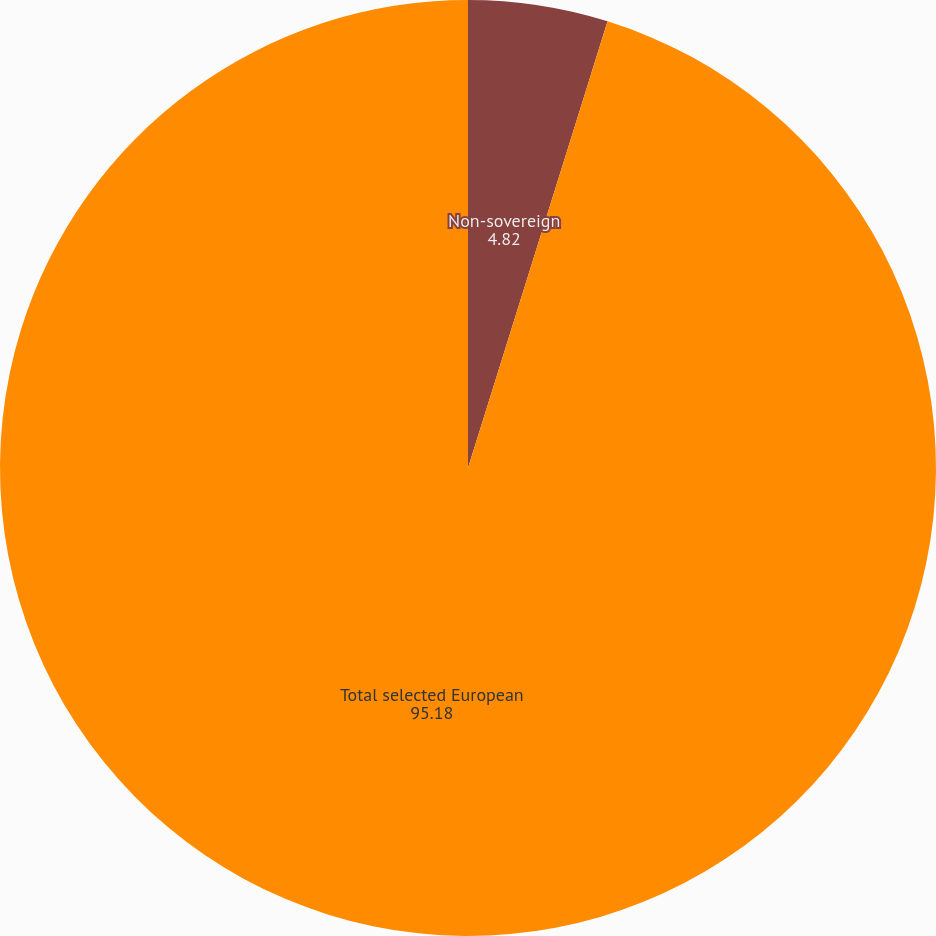<chart> <loc_0><loc_0><loc_500><loc_500><pie_chart><fcel>Non-sovereign<fcel>Total selected European<nl><fcel>4.82%<fcel>95.18%<nl></chart> 